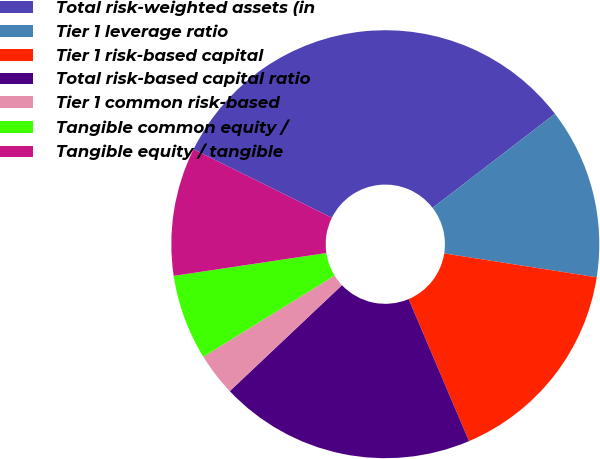Convert chart. <chart><loc_0><loc_0><loc_500><loc_500><pie_chart><fcel>Total risk-weighted assets (in<fcel>Tier 1 leverage ratio<fcel>Tier 1 risk-based capital<fcel>Total risk-based capital ratio<fcel>Tier 1 common risk-based<fcel>Tangible common equity /<fcel>Tangible equity / tangible<nl><fcel>32.25%<fcel>12.9%<fcel>16.13%<fcel>19.35%<fcel>3.23%<fcel>6.45%<fcel>9.68%<nl></chart> 